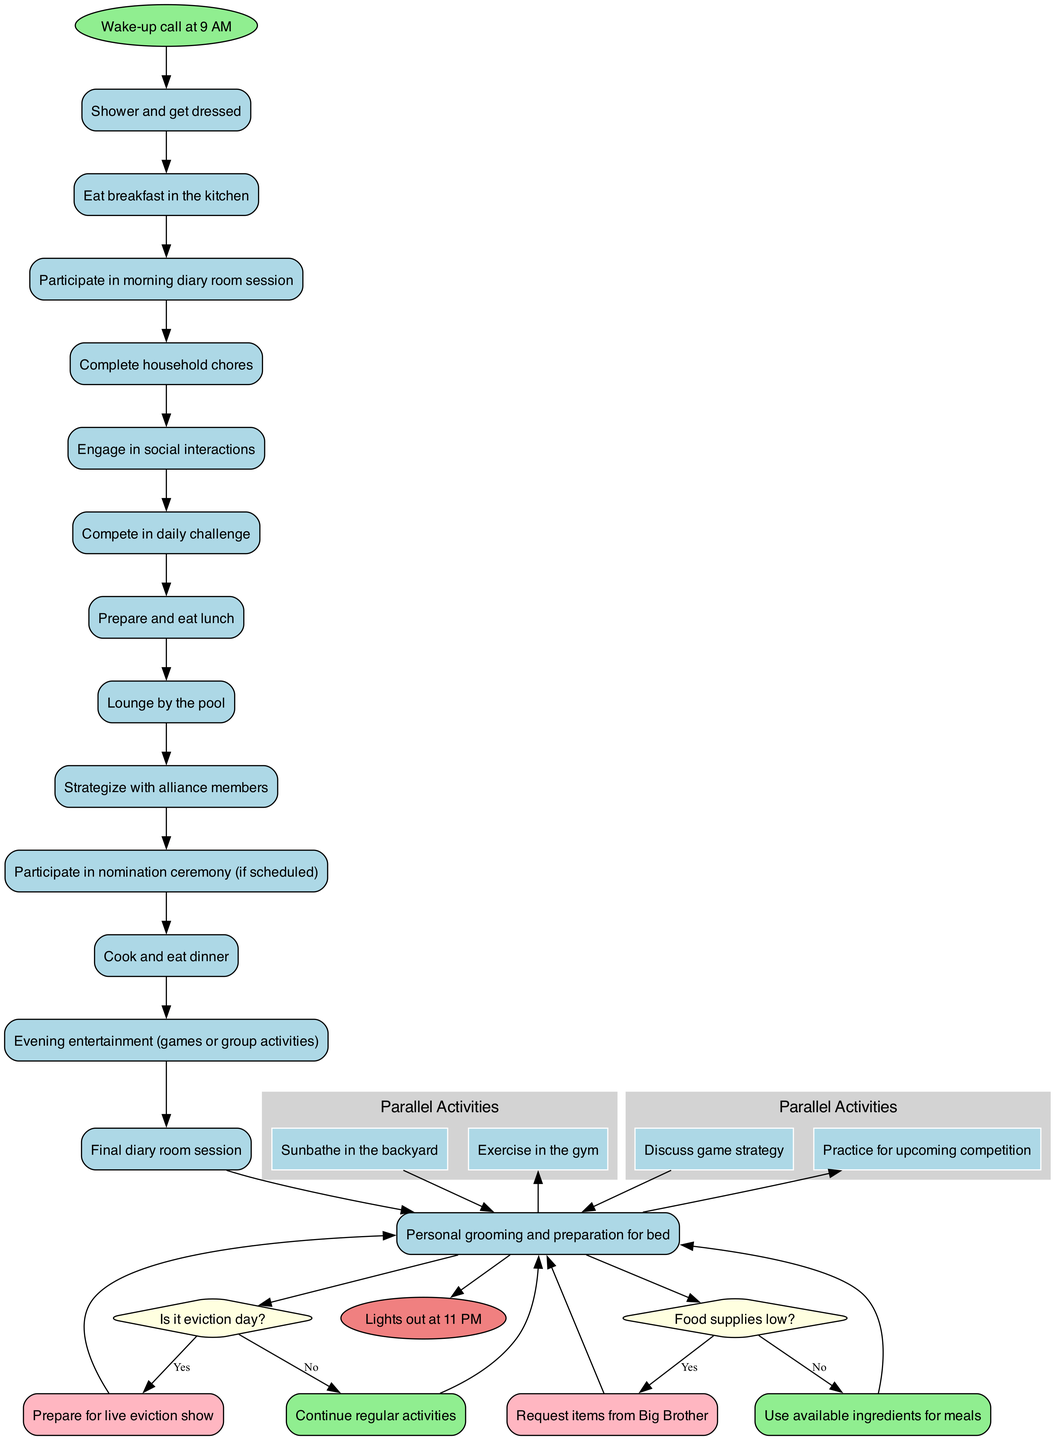What is the starting point of the daily routine? The starting point is indicated by the "start" node in the diagram, which shows "Wake-up call at 9 AM" as the initial activity.
Answer: Wake-up call at 9 AM What is the last activity before lights out? The last activity is represented by the "end" node in the diagram, which shows "Lights out at 11 PM" as the concluding event in the daily routine.
Answer: Lights out at 11 PM How many activities are listed in the diagram? The diagram contains a series of specific nodes for each activity. By counting the activities defined in the data, we find that there are 13 activities listed.
Answer: 13 What decision must be made regarding eviction day? There is a decision point regarding "Is it eviction day?" that has two paths: yes leads to "Prepare for live eviction show" and no leads to "Continue regular activities."
Answer: Prepare for live eviction show or Continue regular activities What happens if food supplies are low? Another decision point asks "Food supplies low?", with a yes path leading to "Request items from Big Brother" and a no path leading to "Use available ingredients for meals."
Answer: Request items from Big Brother or Use available ingredients for meals Which two activities happen in parallel at some point? The diagram contains a section for parallel activities, specifically "Exercise in the gym" and "Sunbathe in the backyard," which are conducted simultaneously.
Answer: Exercise in the gym and Sunbathe in the backyard What activity comes immediately after eating breakfast? By following the flow of activities, "Participate in morning diary room session" directly follows "Eat breakfast in the kitchen."
Answer: Participate in morning diary room session What is the second decision point listed in the diagram? The second decision point is about food supplies, questioning "Food supplies low?" which aims to address meal preparation based on inventory status.
Answer: Food supplies low? What type of activities are included under evening entertainment? The activities labeled as evening entertainment are defined as "games or group activities," indicating the social and recreational nature of these interactions at night.
Answer: games or group activities 